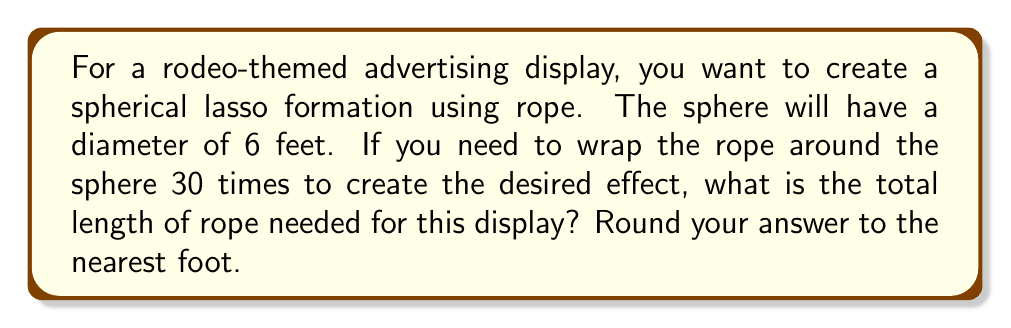Could you help me with this problem? To solve this problem, we need to follow these steps:

1) First, recall the formula for the circumference of a great circle on a sphere:
   $$ C = \pi d $$
   where $C$ is the circumference and $d$ is the diameter.

2) Given the diameter is 6 feet, we can calculate the circumference:
   $$ C = \pi \cdot 6 = 6\pi \approx 18.85 \text{ feet} $$

3) Now, we need to multiply this by the number of times the rope wraps around the sphere (30):
   $$ \text{Total length} = 30 \cdot 6\pi = 180\pi \text{ feet} $$

4) Calculate this value:
   $$ 180\pi \approx 565.49 \text{ feet} $$

5) Rounding to the nearest foot:
   $$ 565.49 \approx 565 \text{ feet} $$

Therefore, you will need approximately 565 feet of rope for your spherical lasso display.
Answer: $565 \text{ feet}$ 